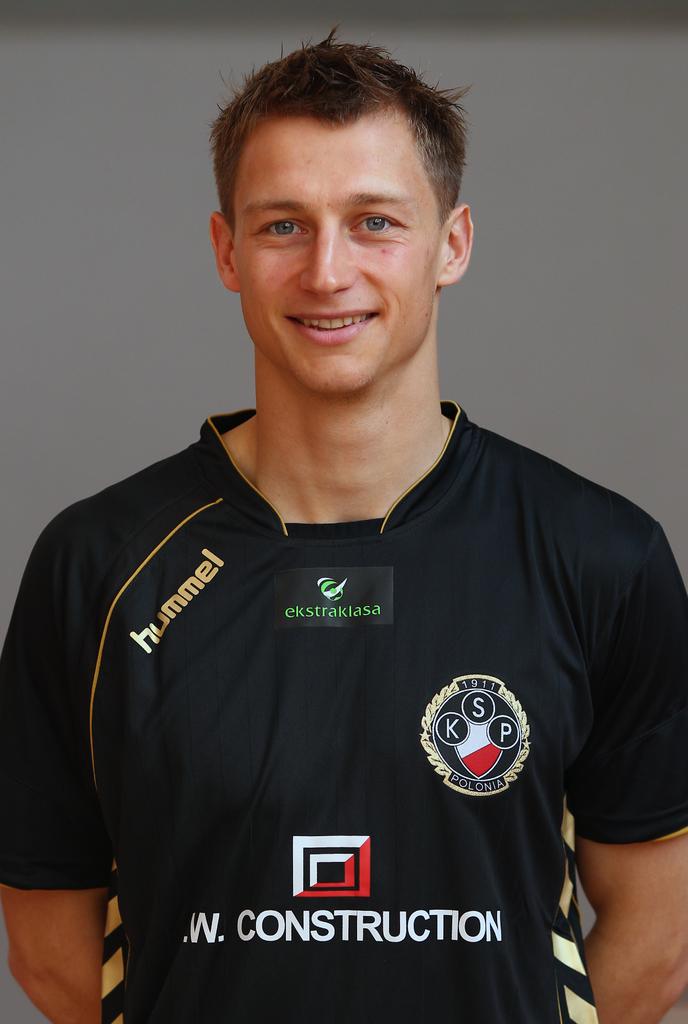What three initials are on the right side of the shirt?
Your answer should be very brief. Ksp. Who is sponsoring this athlete?
Your answer should be very brief. W. construction. 